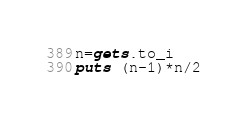<code> <loc_0><loc_0><loc_500><loc_500><_Ruby_>n=gets.to_i
puts (n-1)*n/2
</code> 